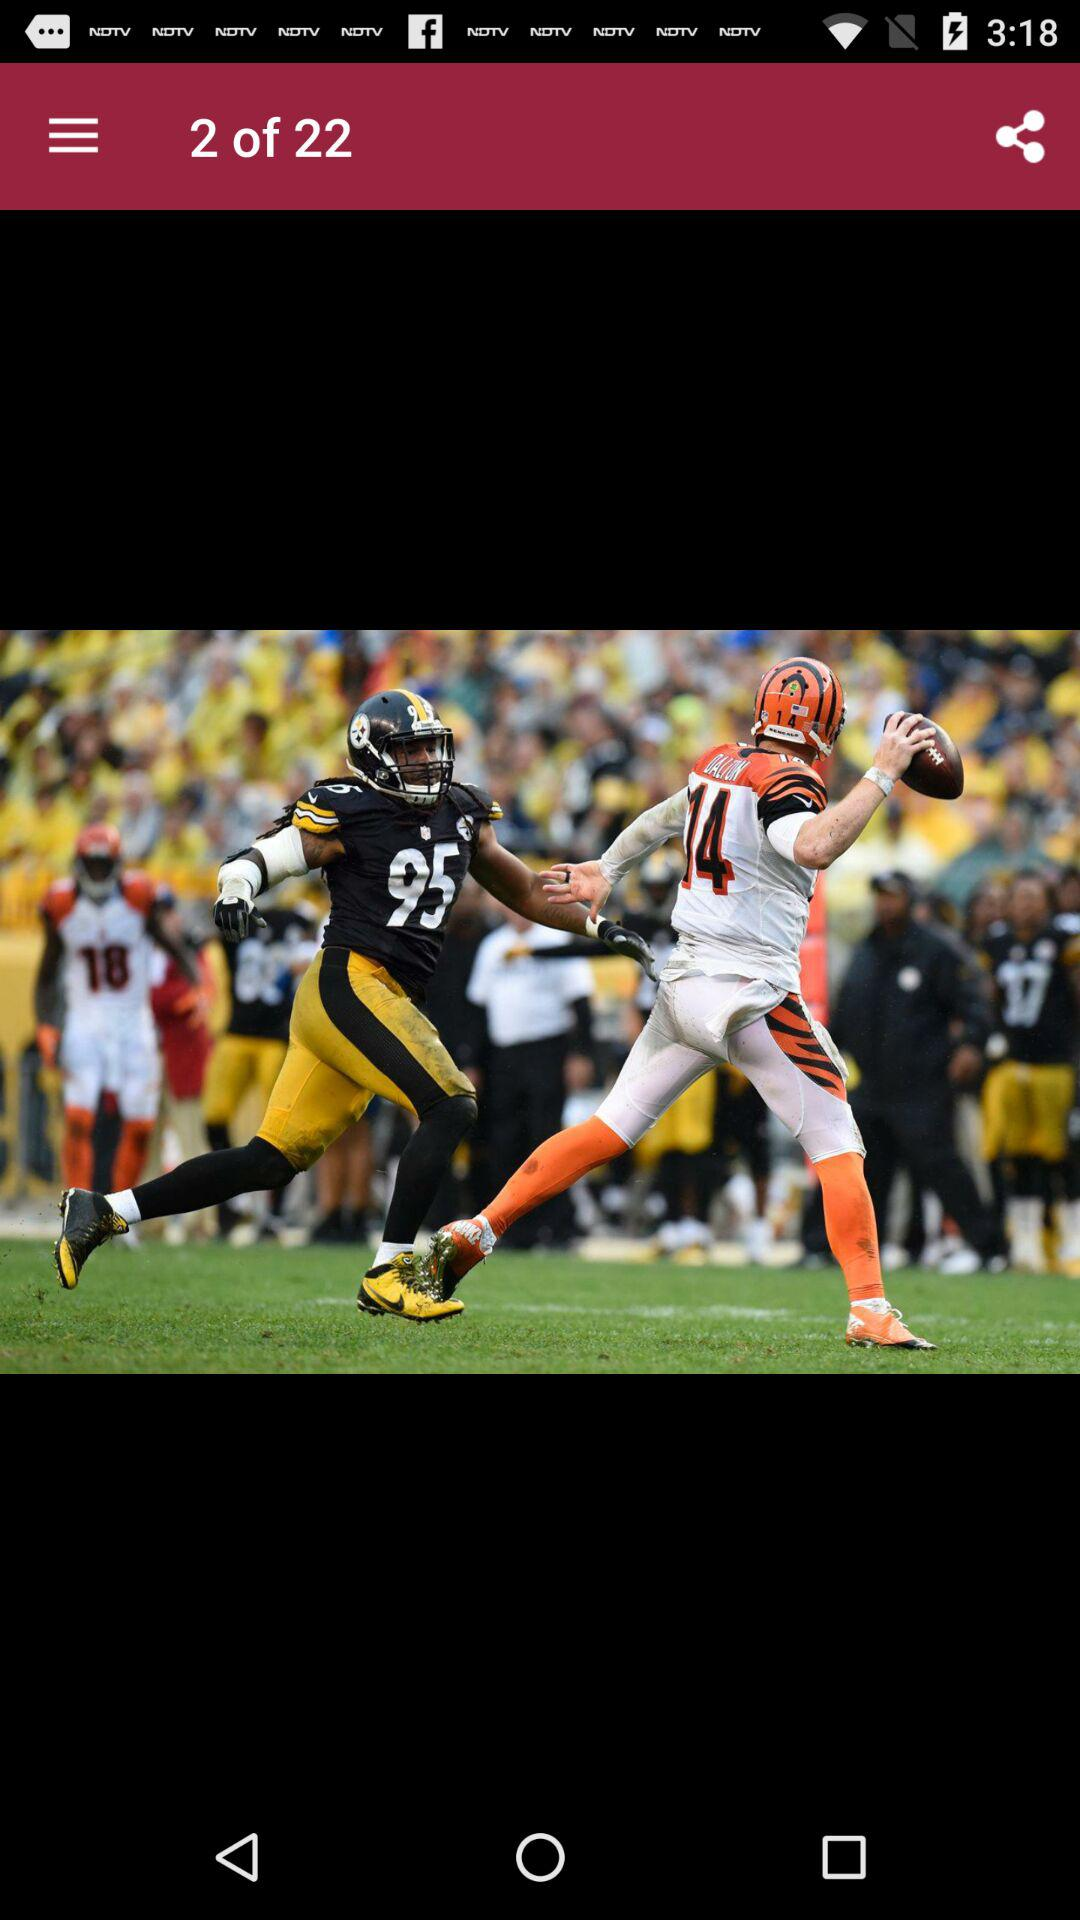Which two teams are pictured?
When the provided information is insufficient, respond with <no answer>. <no answer> 